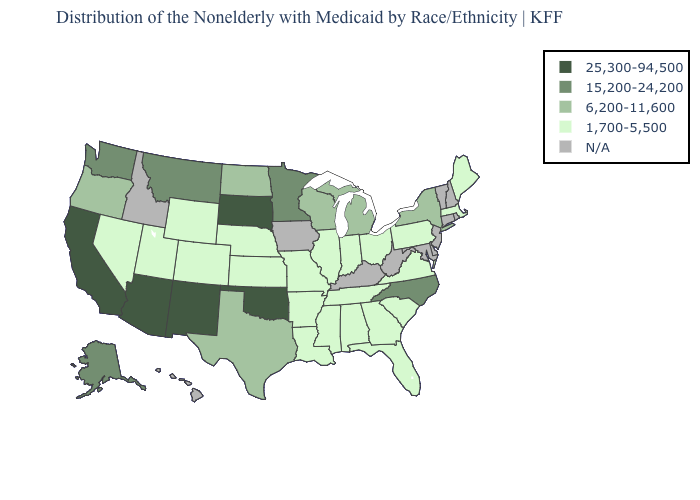Among the states that border Mississippi , which have the lowest value?
Keep it brief. Alabama, Arkansas, Louisiana, Tennessee. Which states have the lowest value in the MidWest?
Quick response, please. Illinois, Indiana, Kansas, Missouri, Nebraska, Ohio. Name the states that have a value in the range 6,200-11,600?
Concise answer only. Michigan, New York, North Dakota, Oregon, Texas, Wisconsin. Which states have the lowest value in the USA?
Short answer required. Alabama, Arkansas, Colorado, Florida, Georgia, Illinois, Indiana, Kansas, Louisiana, Maine, Massachusetts, Mississippi, Missouri, Nebraska, Nevada, Ohio, Pennsylvania, South Carolina, Tennessee, Utah, Virginia, Wyoming. Name the states that have a value in the range 15,200-24,200?
Write a very short answer. Alaska, Minnesota, Montana, North Carolina, Washington. What is the value of Massachusetts?
Write a very short answer. 1,700-5,500. What is the value of North Dakota?
Concise answer only. 6,200-11,600. Among the states that border Arizona , does Colorado have the lowest value?
Quick response, please. Yes. What is the lowest value in the USA?
Concise answer only. 1,700-5,500. What is the lowest value in the USA?
Concise answer only. 1,700-5,500. What is the value of New Hampshire?
Be succinct. N/A. Does Montana have the lowest value in the USA?
Keep it brief. No. What is the value of Maryland?
Keep it brief. N/A. 